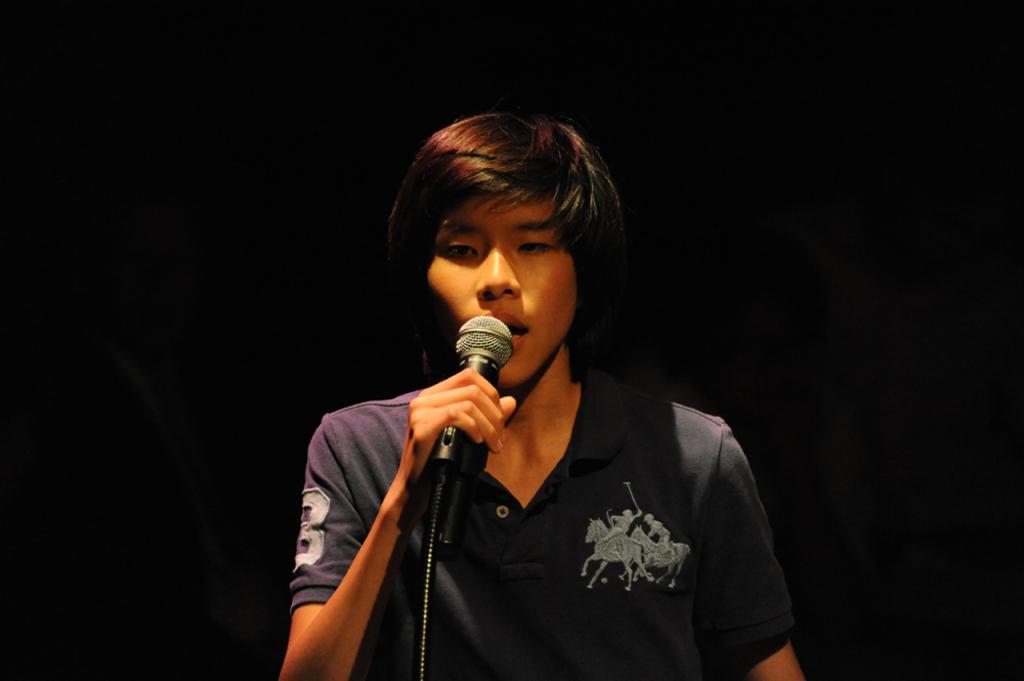How would you summarize this image in a sentence or two? In this image I can see a man and I can see he is holding a mic. I can also see he is wearing t shirt and on his t shirt I can see few logos are printed. I can also see this image is little bit in dark from background. 